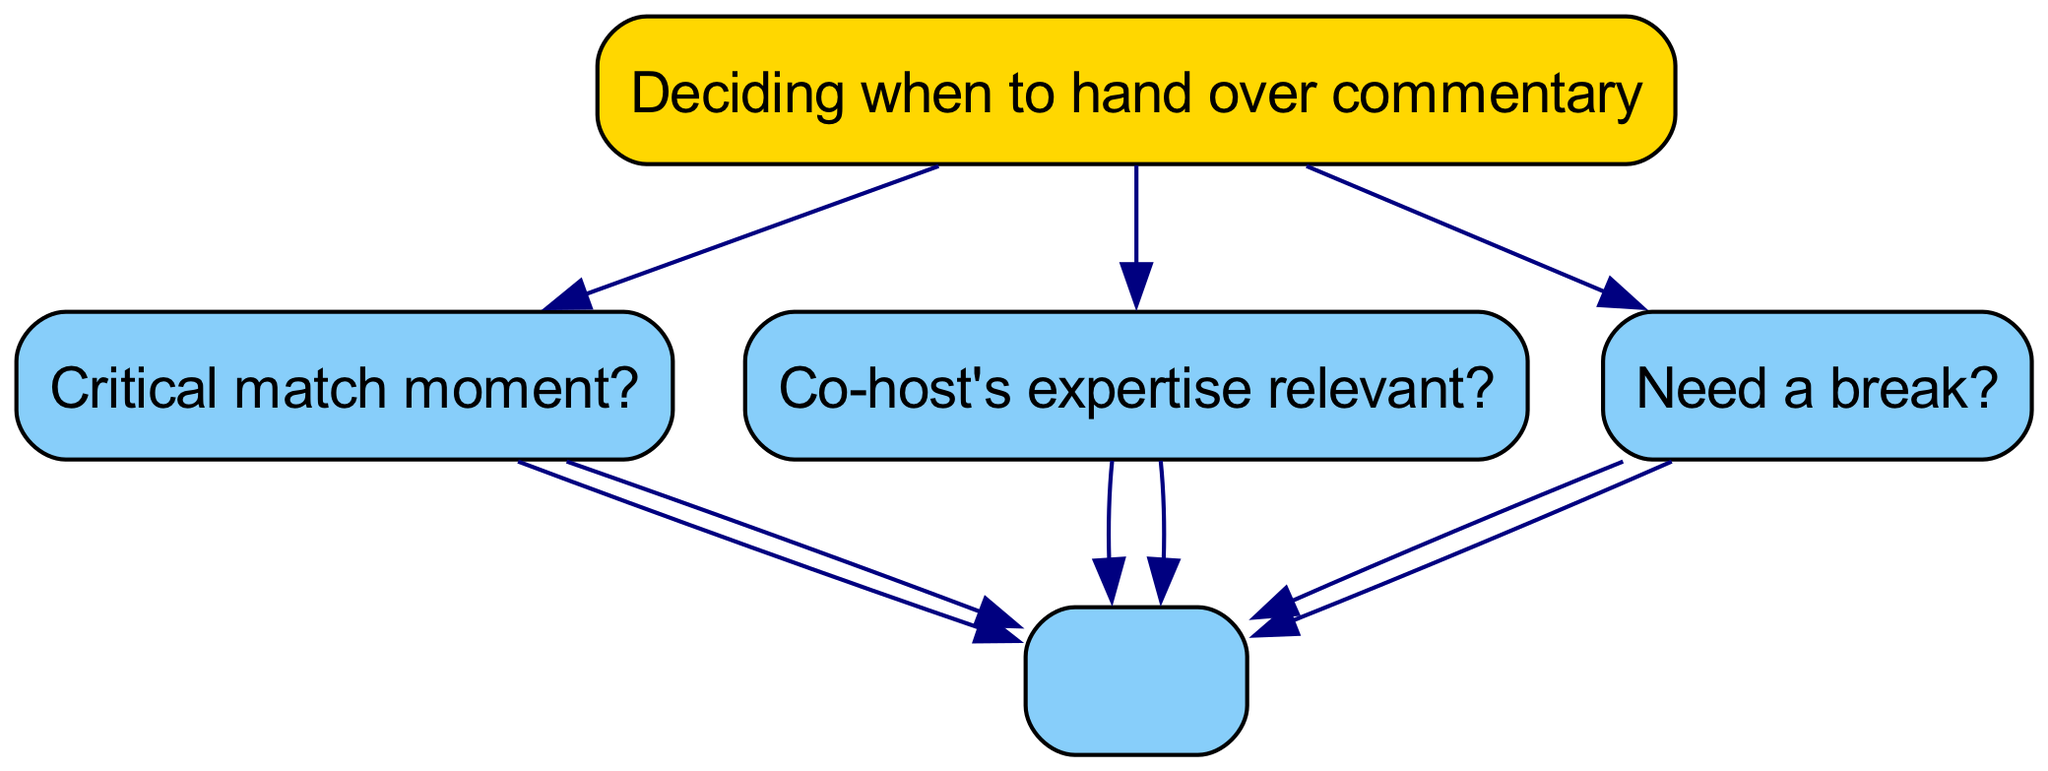What is the root node of the diagram? The root node is the starting point of the decision tree, which is explicitly labeled at the top. It represents the main decision to be made, which is "Deciding when to hand over commentary."
Answer: Deciding when to hand over commentary How many branches are under the root node? The number of branches can be counted by identifying the separate pathways originating from the root. There are three main branches: "Critical match moment?", "Co-host's expertise relevant?", and "Need a break?".
Answer: 3 What happens if a goal is scored during commentary? If a goal is scored, the diagram indicates that the next step is to hand over to the co-host for analysis regarding the celebration. This involves understanding the flow below the "Critical match moment?" decision.
Answer: Hand over to co-host for celebration analysis What is the outcome if the time since the last handover is less than 15 minutes? According to the diagram, when it is determined that the time since the last handover is less than 15 minutes, the action is to continue with the current commentary. This is deduced from the "No" path under the "Time since last handover?" node.
Answer: Continue commentary If a co-host's expertise is relevant, what should the commentator do? The decision flow indicates that if the co-host's expertise is relevant, the commentator should hand over to utilize their knowledge. This is a direct outcome from the "Co-host's expertise relevant?" decision node under its "Yes" branch.
Answer: Hand over to utilize their knowledge What should be done if there is a controversial call? In the case of a controversial call, the diagram suggests that the commentator should continue with the commentary and offer a balanced perspective. This response can be traced in the "Critical match moment?" branch when the answer is "Yes".
Answer: Continue commentary, offer balanced perspective If the commentator needs a break, what is the immediate action? The immediate action when the commentator needs a break is to hand over the commentary and take a short break. This follows logically from the “Need a break?” question under its "Yes" response.
Answer: Hand over and take a short break How does the diagram guide on variety in commentary? The diagram suggests considering handing over for variety if the time since the last handover exceeds 15 minutes. This flow can be found in the branches stemming from "Time since last handover?" where "greater than 15 minutes" leads to this consideration.
Answer: Consider handing over for variety What should be done if the co-host's expertise is not relevant? If the co-host's expertise is determined to be irrelevant, the action is to continue with the current commentary. This is specified in the flow under the "Co-host's expertise relevant?" node when the answer is "No."
Answer: Continue with current commentary 